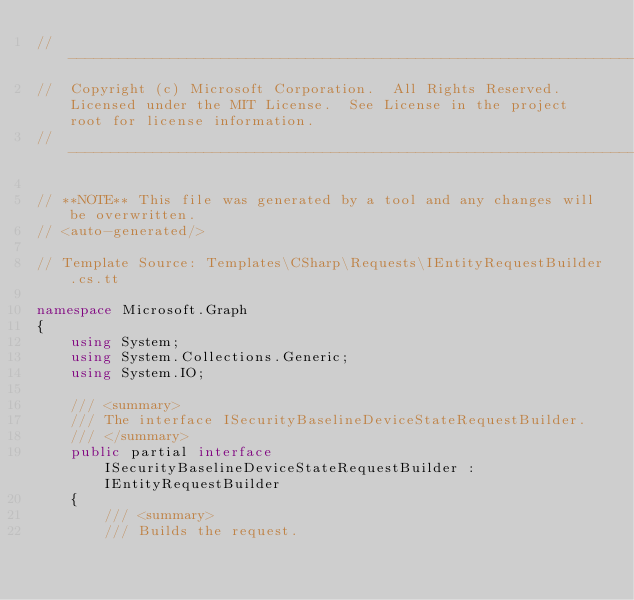<code> <loc_0><loc_0><loc_500><loc_500><_C#_>// ------------------------------------------------------------------------------
//  Copyright (c) Microsoft Corporation.  All Rights Reserved.  Licensed under the MIT License.  See License in the project root for license information.
// ------------------------------------------------------------------------------

// **NOTE** This file was generated by a tool and any changes will be overwritten.
// <auto-generated/>

// Template Source: Templates\CSharp\Requests\IEntityRequestBuilder.cs.tt

namespace Microsoft.Graph
{
    using System;
    using System.Collections.Generic;
    using System.IO;

    /// <summary>
    /// The interface ISecurityBaselineDeviceStateRequestBuilder.
    /// </summary>
    public partial interface ISecurityBaselineDeviceStateRequestBuilder : IEntityRequestBuilder
    {
        /// <summary>
        /// Builds the request.</code> 